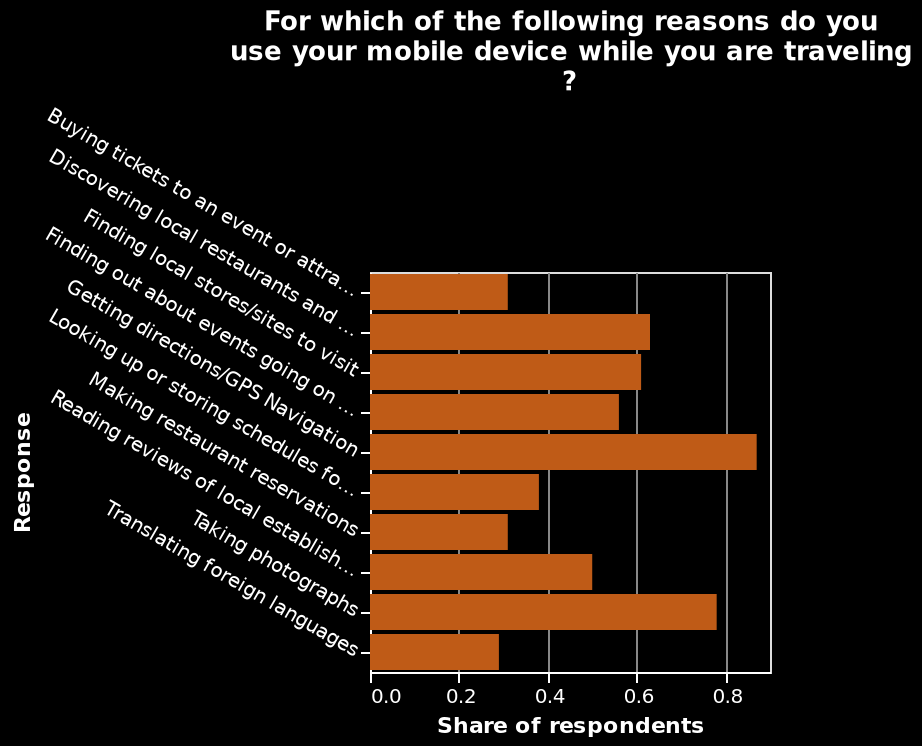<image>
What is the label for the y-axis in the bar plot? The label for the y-axis in the bar plot is "Response". What is the label for the x-axis in the bar plot? The label for the x-axis in the bar plot is "Share of respondents". 